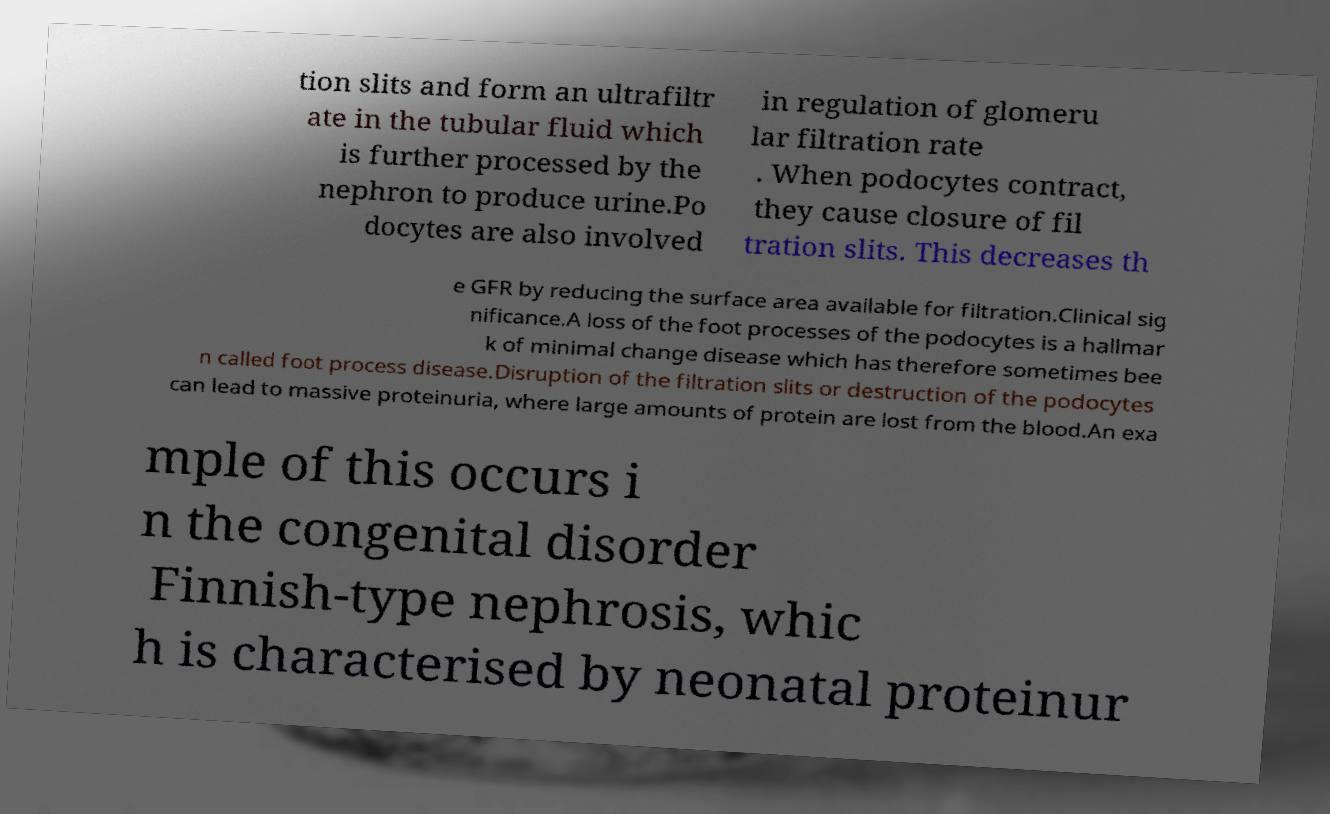There's text embedded in this image that I need extracted. Can you transcribe it verbatim? tion slits and form an ultrafiltr ate in the tubular fluid which is further processed by the nephron to produce urine.Po docytes are also involved in regulation of glomeru lar filtration rate . When podocytes contract, they cause closure of fil tration slits. This decreases th e GFR by reducing the surface area available for filtration.Clinical sig nificance.A loss of the foot processes of the podocytes is a hallmar k of minimal change disease which has therefore sometimes bee n called foot process disease.Disruption of the filtration slits or destruction of the podocytes can lead to massive proteinuria, where large amounts of protein are lost from the blood.An exa mple of this occurs i n the congenital disorder Finnish-type nephrosis, whic h is characterised by neonatal proteinur 